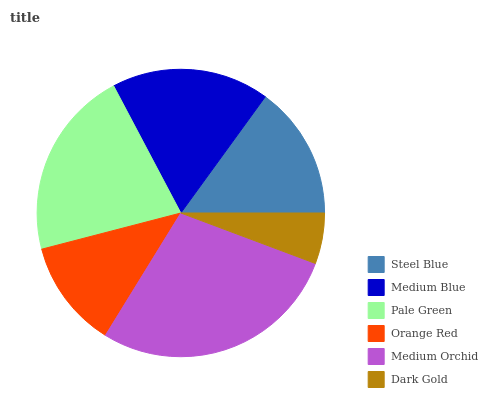Is Dark Gold the minimum?
Answer yes or no. Yes. Is Medium Orchid the maximum?
Answer yes or no. Yes. Is Medium Blue the minimum?
Answer yes or no. No. Is Medium Blue the maximum?
Answer yes or no. No. Is Medium Blue greater than Steel Blue?
Answer yes or no. Yes. Is Steel Blue less than Medium Blue?
Answer yes or no. Yes. Is Steel Blue greater than Medium Blue?
Answer yes or no. No. Is Medium Blue less than Steel Blue?
Answer yes or no. No. Is Medium Blue the high median?
Answer yes or no. Yes. Is Steel Blue the low median?
Answer yes or no. Yes. Is Dark Gold the high median?
Answer yes or no. No. Is Medium Orchid the low median?
Answer yes or no. No. 